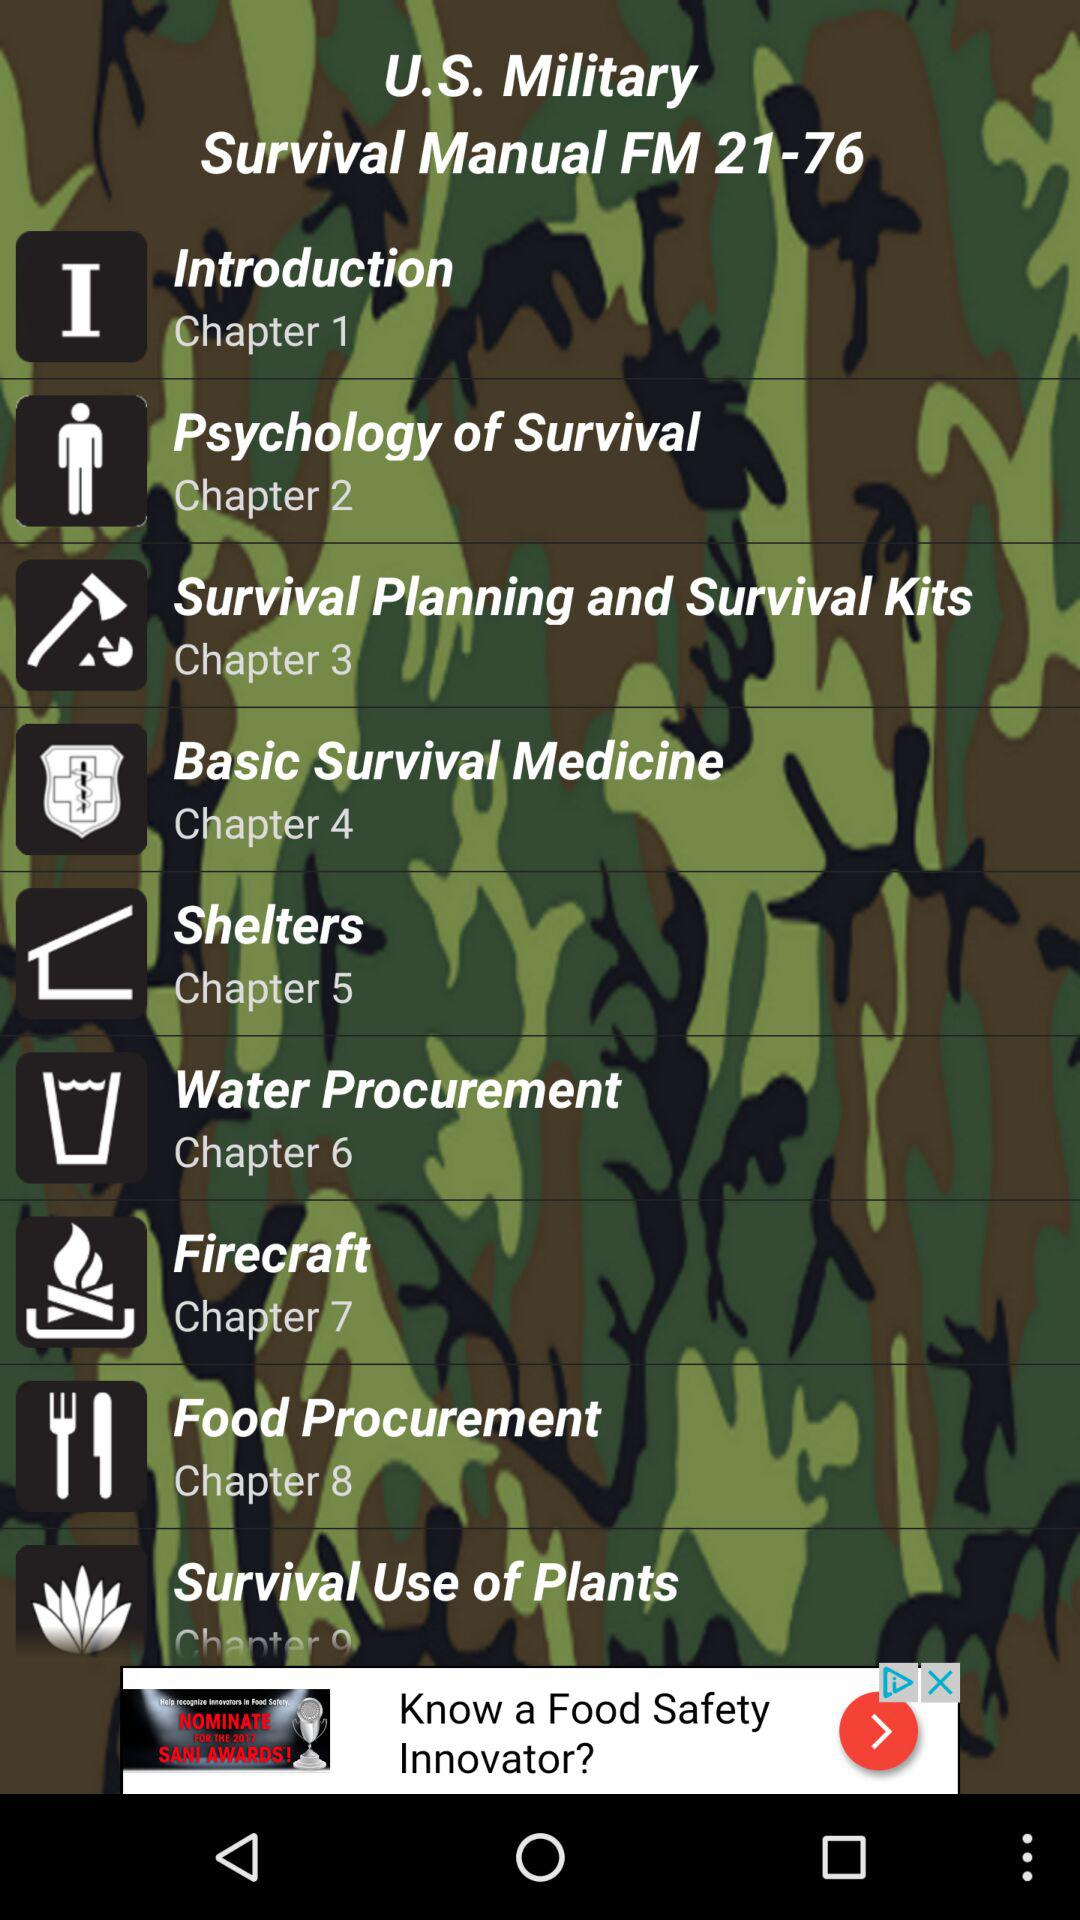What is the title of chapter 2? The title of chapter 2 is "Psychology of Survival". 